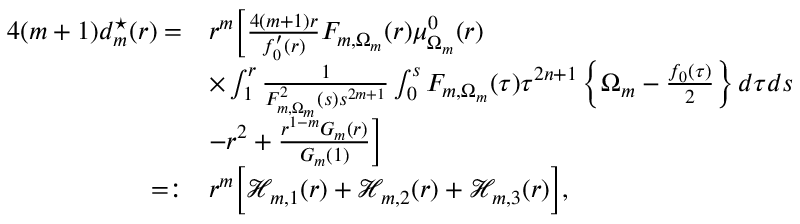<formula> <loc_0><loc_0><loc_500><loc_500>\begin{array} { r l } { 4 ( m + 1 ) d _ { m } ^ { ^ { * } } ( r ) = } & { r ^ { m } \left [ \frac { 4 ( m + 1 ) r } { f _ { 0 } ^ { \prime } ( r ) } F _ { m , \Omega _ { m } } ( r ) \mu _ { \Omega _ { m } } ^ { 0 } ( r ) } \\ & { \times \int _ { 1 } ^ { r } \frac { 1 } { F _ { m , \Omega _ { m } } ^ { 2 } ( s ) s ^ { 2 m + 1 } } \int _ { 0 } ^ { s } F _ { m , \Omega _ { m } } ( \tau ) \tau ^ { 2 n + 1 } \left \{ \Omega _ { m } - \frac { f _ { 0 } ( \tau ) } { 2 } \right \} d \tau d s } \\ & { - r ^ { 2 } + \frac { r ^ { 1 - m } G _ { m } ( r ) } { G _ { m } ( 1 ) } \right ] } \\ { = \colon } & { r ^ { m } \left [ \mathcal { H } _ { m , 1 } ( r ) + \mathcal { H } _ { m , 2 } ( r ) + \mathcal { H } _ { m , 3 } ( r ) \right ] , } \end{array}</formula> 